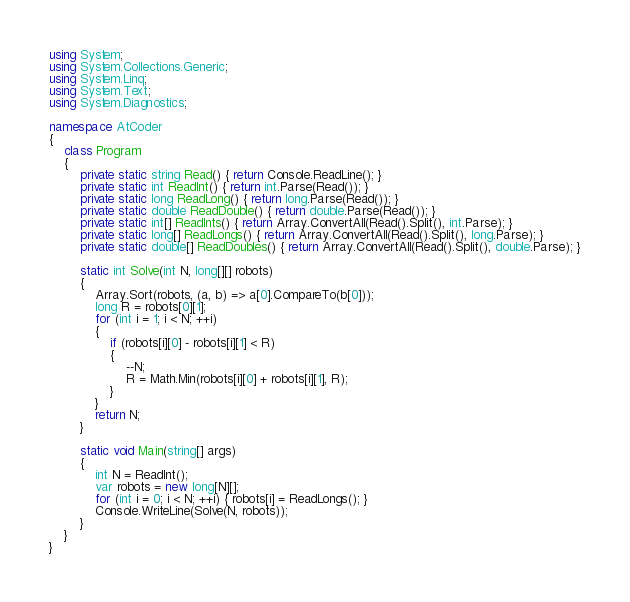<code> <loc_0><loc_0><loc_500><loc_500><_C#_>using System;
using System.Collections.Generic;
using System.Linq;
using System.Text;
using System.Diagnostics;

namespace AtCoder
{
    class Program
    {
        private static string Read() { return Console.ReadLine(); }
        private static int ReadInt() { return int.Parse(Read()); }
        private static long ReadLong() { return long.Parse(Read()); }
        private static double ReadDouble() { return double.Parse(Read()); }
        private static int[] ReadInts() { return Array.ConvertAll(Read().Split(), int.Parse); }
        private static long[] ReadLongs() { return Array.ConvertAll(Read().Split(), long.Parse); }
        private static double[] ReadDoubles() { return Array.ConvertAll(Read().Split(), double.Parse); }

        static int Solve(int N, long[][] robots)
        {
            Array.Sort(robots, (a, b) => a[0].CompareTo(b[0]));
            long R = robots[0][1];
            for (int i = 1; i < N; ++i)
            {
                if (robots[i][0] - robots[i][1] < R)
                {
                    --N;
                    R = Math.Min(robots[i][0] + robots[i][1], R);
                }
            }
            return N;
        }

        static void Main(string[] args)
        {
            int N = ReadInt();
            var robots = new long[N][];
            for (int i = 0; i < N; ++i) { robots[i] = ReadLongs(); }
            Console.WriteLine(Solve(N, robots));
        }
    }
}
</code> 